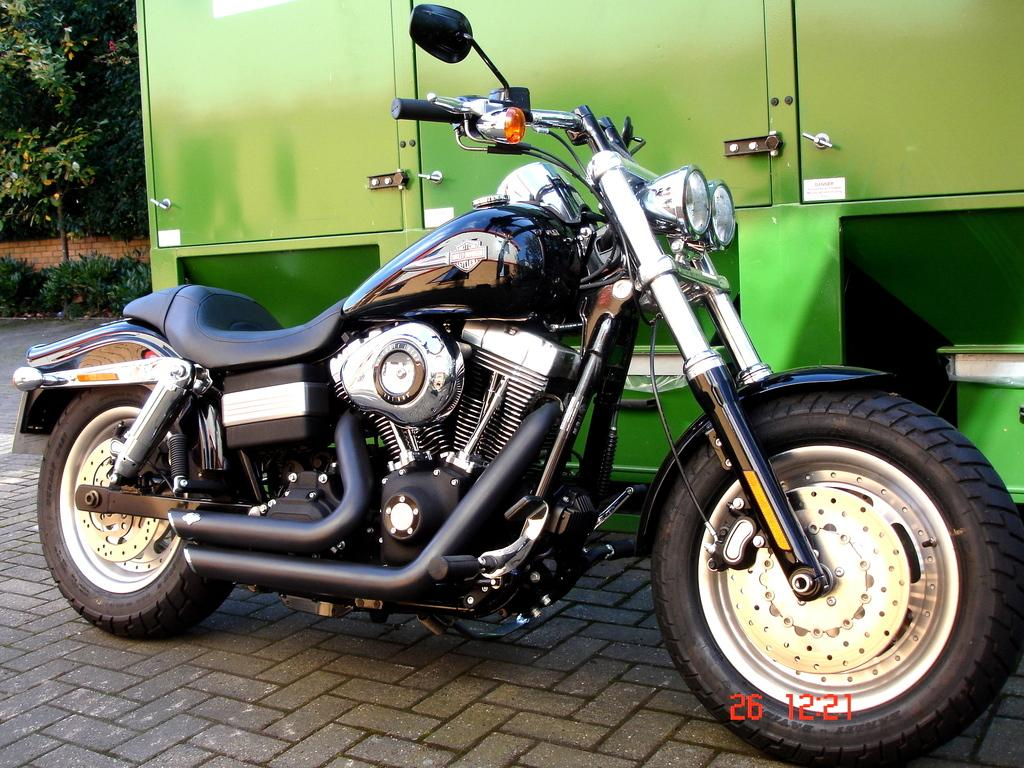What is the main subject in the foreground of the picture? There is a bike in the foreground of the picture. What is the bike's position in relation to the payment? The bike is on a payment. What other vehicle can be seen in the image? There is a vehicle beside the bike. What can be seen in the top left corner of the image? There are plants, a wall, and trees in the top left corner of the image. Can you see the boot of the person riding the bike in the image? There is no person riding the bike in the image, so it is not possible to see their boot. 